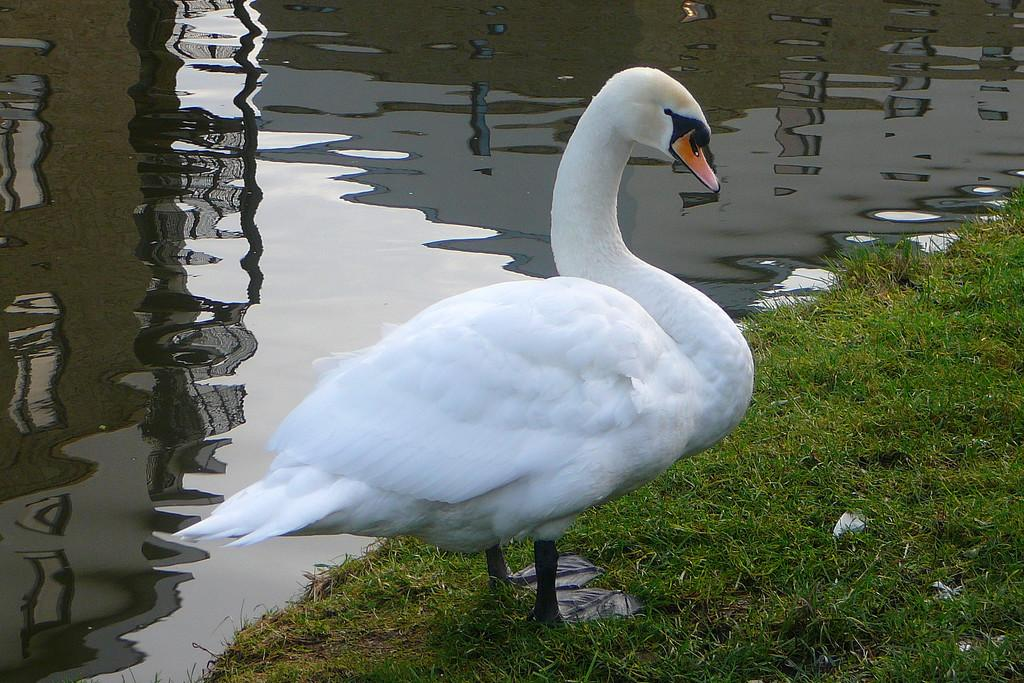What type of animal is present in the image? There is a bird in the image. What color is the bird? The bird is white in color. What is the color of the grass in the image? The grass in the image is green. What can be seen in the background of the image? There is water visible in the background of the image. What type of jeans is the bird wearing in the image? There are no jeans present in the image, as birds do not wear clothing. 